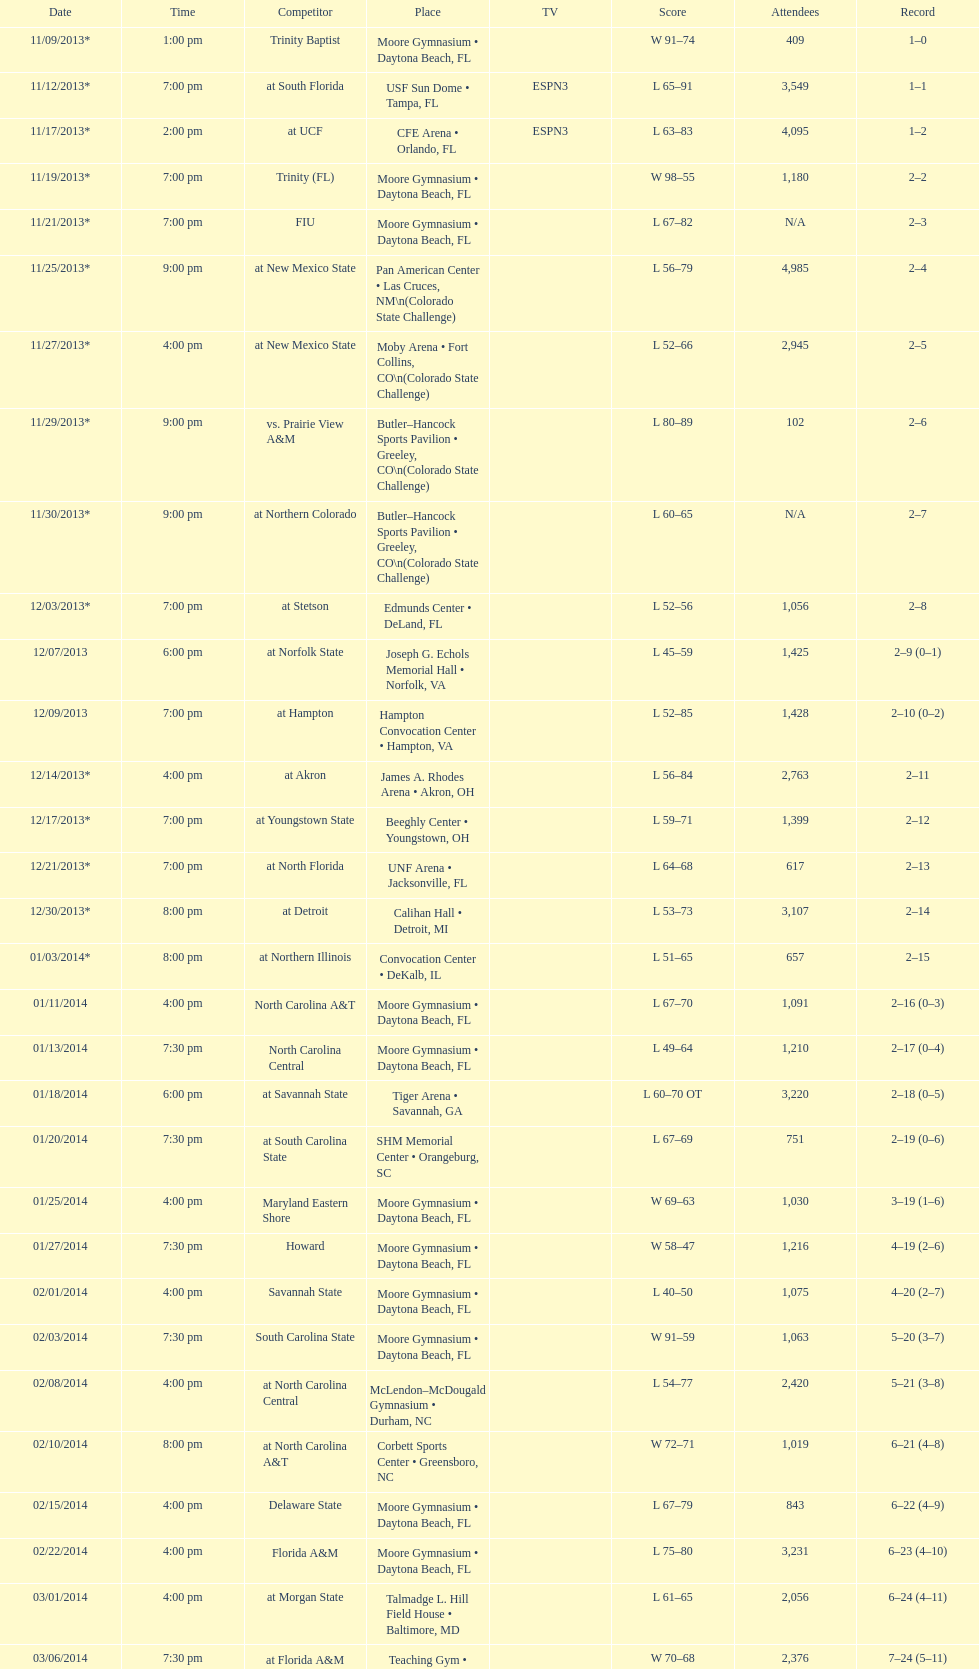Which game was won by a bigger margin, against trinity (fl) or against trinity baptist? Trinity (FL). 